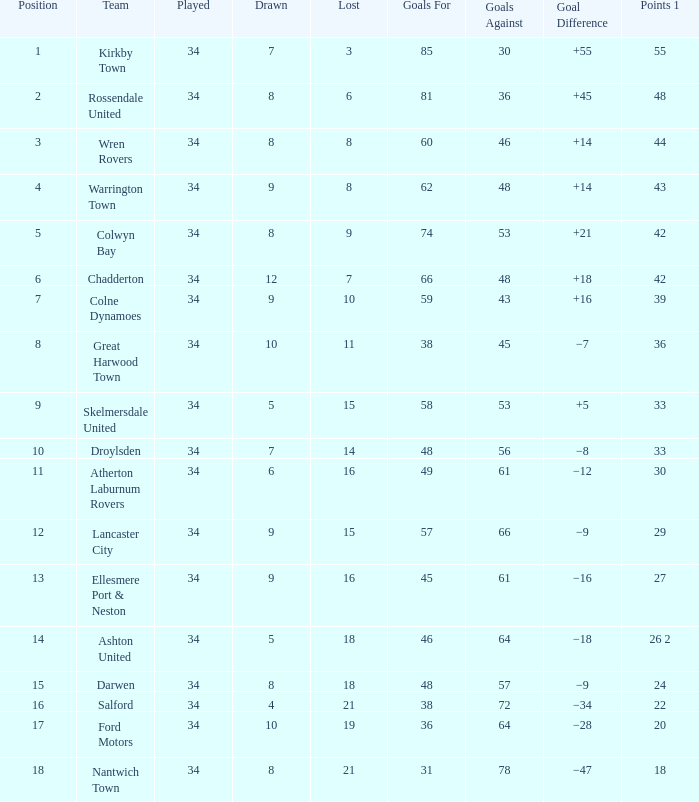What is the cumulative count of positions when over 48 goals are scored against, 1 out of 29 points is played, and under 34 games are completed? 0.0. 